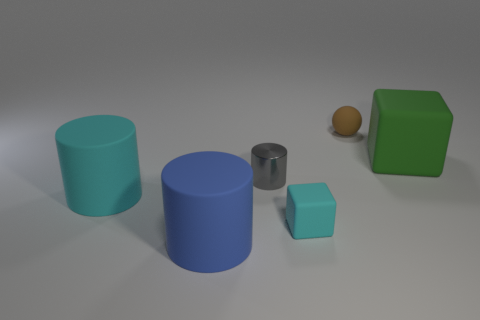Can you describe the sizes and colors of the objects starting from the left? From the left, there is a large turquoise cylinder, a medium-sized blue cylinder, a small silver cylinder, a small aqua cube, a very small orange sphere, and at the right end, a large green cube. 